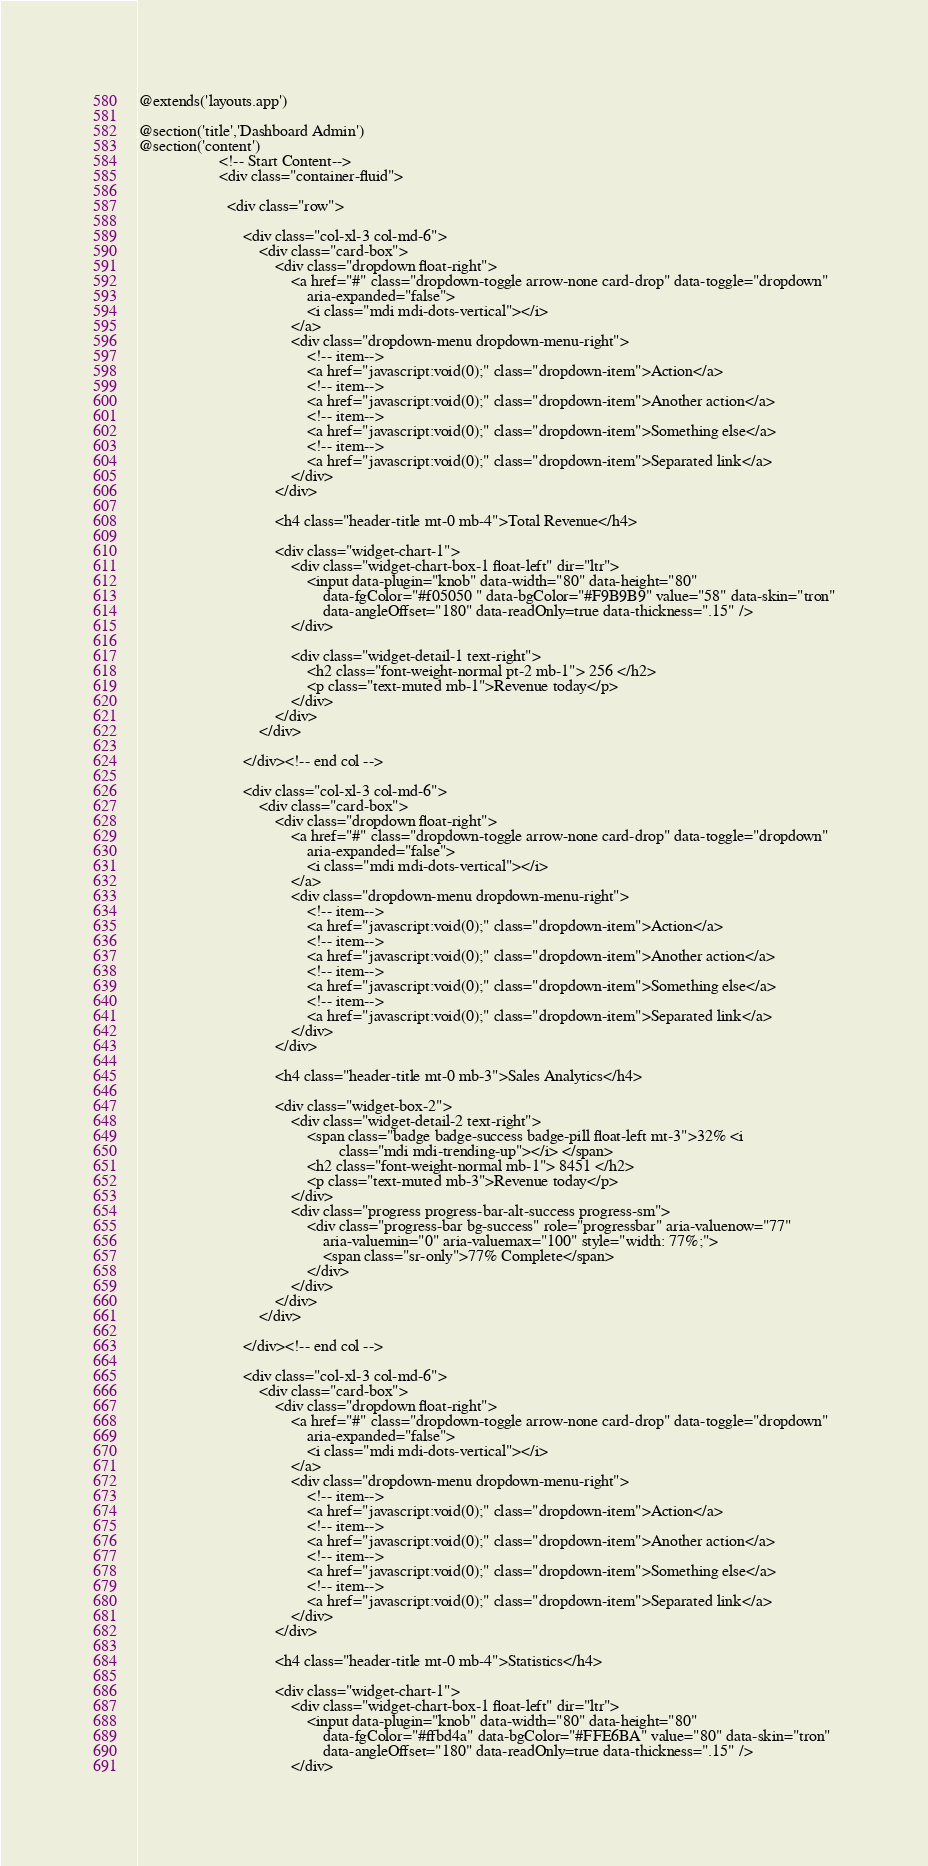Convert code to text. <code><loc_0><loc_0><loc_500><loc_500><_PHP_>@extends('layouts.app')

@section('title','Dashboard Admin')
@section('content')
                    <!-- Start Content-->
                    <div class="container-fluid">

                      <div class="row">
  
                          <div class="col-xl-3 col-md-6">
                              <div class="card-box">
                                  <div class="dropdown float-right">
                                      <a href="#" class="dropdown-toggle arrow-none card-drop" data-toggle="dropdown"
                                          aria-expanded="false">
                                          <i class="mdi mdi-dots-vertical"></i>
                                      </a>
                                      <div class="dropdown-menu dropdown-menu-right">
                                          <!-- item-->
                                          <a href="javascript:void(0);" class="dropdown-item">Action</a>
                                          <!-- item-->
                                          <a href="javascript:void(0);" class="dropdown-item">Another action</a>
                                          <!-- item-->
                                          <a href="javascript:void(0);" class="dropdown-item">Something else</a>
                                          <!-- item-->
                                          <a href="javascript:void(0);" class="dropdown-item">Separated link</a>
                                      </div>
                                  </div>
  
                                  <h4 class="header-title mt-0 mb-4">Total Revenue</h4>
  
                                  <div class="widget-chart-1">
                                      <div class="widget-chart-box-1 float-left" dir="ltr">
                                          <input data-plugin="knob" data-width="80" data-height="80"
                                              data-fgColor="#f05050 " data-bgColor="#F9B9B9" value="58" data-skin="tron"
                                              data-angleOffset="180" data-readOnly=true data-thickness=".15" />
                                      </div>
  
                                      <div class="widget-detail-1 text-right">
                                          <h2 class="font-weight-normal pt-2 mb-1"> 256 </h2>
                                          <p class="text-muted mb-1">Revenue today</p>
                                      </div>
                                  </div>
                              </div>
  
                          </div><!-- end col -->
  
                          <div class="col-xl-3 col-md-6">
                              <div class="card-box">
                                  <div class="dropdown float-right">
                                      <a href="#" class="dropdown-toggle arrow-none card-drop" data-toggle="dropdown"
                                          aria-expanded="false">
                                          <i class="mdi mdi-dots-vertical"></i>
                                      </a>
                                      <div class="dropdown-menu dropdown-menu-right">
                                          <!-- item-->
                                          <a href="javascript:void(0);" class="dropdown-item">Action</a>
                                          <!-- item-->
                                          <a href="javascript:void(0);" class="dropdown-item">Another action</a>
                                          <!-- item-->
                                          <a href="javascript:void(0);" class="dropdown-item">Something else</a>
                                          <!-- item-->
                                          <a href="javascript:void(0);" class="dropdown-item">Separated link</a>
                                      </div>
                                  </div>
  
                                  <h4 class="header-title mt-0 mb-3">Sales Analytics</h4>
  
                                  <div class="widget-box-2">
                                      <div class="widget-detail-2 text-right">
                                          <span class="badge badge-success badge-pill float-left mt-3">32% <i
                                                  class="mdi mdi-trending-up"></i> </span>
                                          <h2 class="font-weight-normal mb-1"> 8451 </h2>
                                          <p class="text-muted mb-3">Revenue today</p>
                                      </div>
                                      <div class="progress progress-bar-alt-success progress-sm">
                                          <div class="progress-bar bg-success" role="progressbar" aria-valuenow="77"
                                              aria-valuemin="0" aria-valuemax="100" style="width: 77%;">
                                              <span class="sr-only">77% Complete</span>
                                          </div>
                                      </div>
                                  </div>
                              </div>
  
                          </div><!-- end col -->
  
                          <div class="col-xl-3 col-md-6">
                              <div class="card-box">
                                  <div class="dropdown float-right">
                                      <a href="#" class="dropdown-toggle arrow-none card-drop" data-toggle="dropdown"
                                          aria-expanded="false">
                                          <i class="mdi mdi-dots-vertical"></i>
                                      </a>
                                      <div class="dropdown-menu dropdown-menu-right">
                                          <!-- item-->
                                          <a href="javascript:void(0);" class="dropdown-item">Action</a>
                                          <!-- item-->
                                          <a href="javascript:void(0);" class="dropdown-item">Another action</a>
                                          <!-- item-->
                                          <a href="javascript:void(0);" class="dropdown-item">Something else</a>
                                          <!-- item-->
                                          <a href="javascript:void(0);" class="dropdown-item">Separated link</a>
                                      </div>
                                  </div>
  
                                  <h4 class="header-title mt-0 mb-4">Statistics</h4>
  
                                  <div class="widget-chart-1">
                                      <div class="widget-chart-box-1 float-left" dir="ltr">
                                          <input data-plugin="knob" data-width="80" data-height="80"
                                              data-fgColor="#ffbd4a" data-bgColor="#FFE6BA" value="80" data-skin="tron"
                                              data-angleOffset="180" data-readOnly=true data-thickness=".15" />
                                      </div></code> 